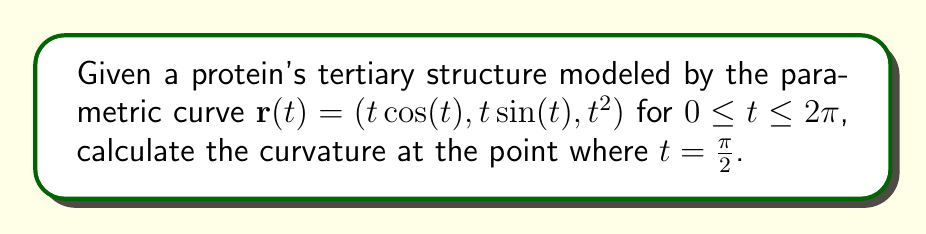Could you help me with this problem? To find the curvature of the protein's tertiary structure, we'll use the formula for curvature of a parametric curve in 3D space:

$$\kappa = \frac{\|\mathbf{r}'(t) \times \mathbf{r}''(t)\|}{\|\mathbf{r}'(t)\|^3}$$

Step 1: Calculate $\mathbf{r}'(t)$
$$\mathbf{r}'(t) = (\cos(t) - t\sin(t), \sin(t) + t\cos(t), 2t)$$

Step 2: Calculate $\mathbf{r}''(t)$
$$\mathbf{r}''(t) = (-2\sin(t) - t\cos(t), 2\cos(t) - t\sin(t), 2)$$

Step 3: Evaluate $\mathbf{r}'(t)$ and $\mathbf{r}''(t)$ at $t = \frac{\pi}{2}$
$$\mathbf{r}'(\frac{\pi}{2}) = (-\frac{\pi}{2}, 1, \pi)$$
$$\mathbf{r}''(\frac{\pi}{2}) = (-1, -\frac{\pi}{2}, 2)$$

Step 4: Calculate $\mathbf{r}'(\frac{\pi}{2}) \times \mathbf{r}''(\frac{\pi}{2})$
$$\mathbf{r}'(\frac{\pi}{2}) \times \mathbf{r}''(\frac{\pi}{2}) = \begin{vmatrix}
\mathbf{i} & \mathbf{j} & \mathbf{k} \\
-\frac{\pi}{2} & 1 & \pi \\
-1 & -\frac{\pi}{2} & 2
\end{vmatrix} = (-\frac{\pi^2}{2} - 2)\mathbf{i} + (\frac{\pi^2}{2} - \pi)\mathbf{j} + (\frac{\pi^2}{4} - 1)\mathbf{k}$$

Step 5: Calculate $\|\mathbf{r}'(\frac{\pi}{2}) \times \mathbf{r}''(\frac{\pi}{2})\|$
$$\|\mathbf{r}'(\frac{\pi}{2}) \times \mathbf{r}''(\frac{\pi}{2})\| = \sqrt{(-\frac{\pi^2}{2} - 2)^2 + (\frac{\pi^2}{2} - \pi)^2 + (\frac{\pi^2}{4} - 1)^2}$$

Step 6: Calculate $\|\mathbf{r}'(\frac{\pi}{2})\|^3$
$$\|\mathbf{r}'(\frac{\pi}{2})\|^3 = ((-\frac{\pi}{2})^2 + 1^2 + \pi^2)^{\frac{3}{2}} = (\frac{5\pi^2}{4} + 1)^{\frac{3}{2}}$$

Step 7: Apply the curvature formula
$$\kappa = \frac{\sqrt{(-\frac{\pi^2}{2} - 2)^2 + (\frac{\pi^2}{2} - \pi)^2 + (\frac{\pi^2}{4} - 1)^2}}{(\frac{5\pi^2}{4} + 1)^{\frac{3}{2}}}$$
Answer: $\kappa = \frac{\sqrt{(-\frac{\pi^2}{2} - 2)^2 + (\frac{\pi^2}{2} - \pi)^2 + (\frac{\pi^2}{4} - 1)^2}}{(\frac{5\pi^2}{4} + 1)^{\frac{3}{2}}}$ 